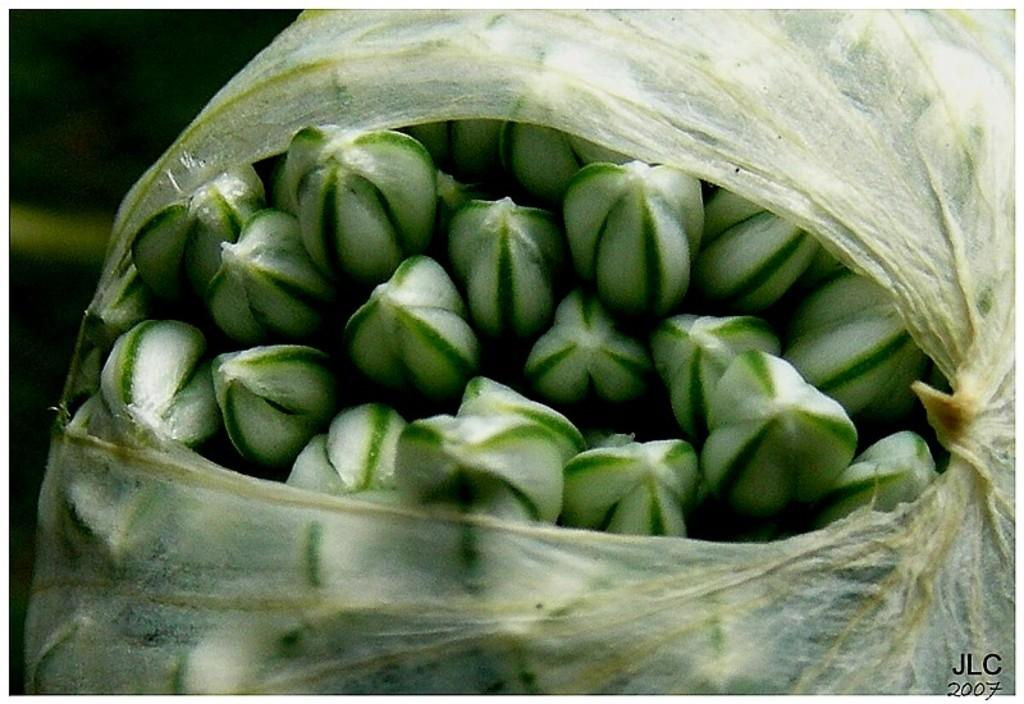What colors are present in the objects in the image? The objects in the image have green and white colors. How are the green and white color things covered in the image? The green and white color things are covered by a white color cover. Can you identify any additional features in the image? Yes, there is a watermark visible in the image. How does the fog affect the visibility of the green and white color things in the image? There is no fog present in the image, so it does not affect the visibility of the green and white color things. What type of pies are being served to the relation in the image? There are no pies or relations present in the image; it only features green and white color things covered by a white color cover and a visible watermark. 